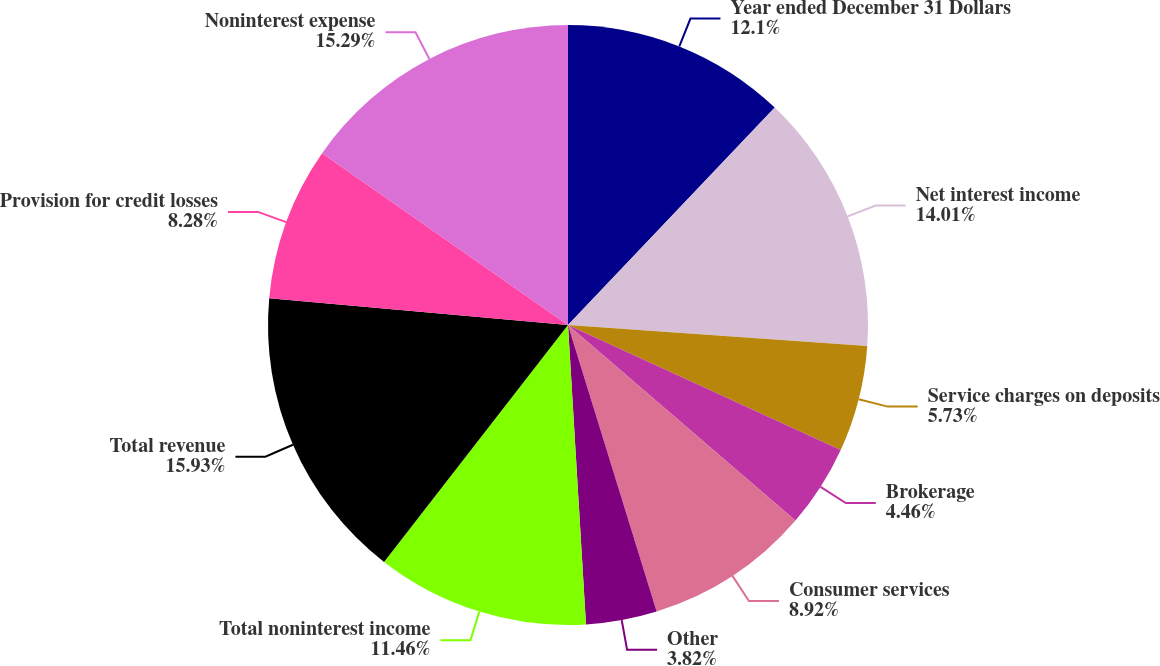<chart> <loc_0><loc_0><loc_500><loc_500><pie_chart><fcel>Year ended December 31 Dollars<fcel>Net interest income<fcel>Service charges on deposits<fcel>Brokerage<fcel>Consumer services<fcel>Other<fcel>Total noninterest income<fcel>Total revenue<fcel>Provision for credit losses<fcel>Noninterest expense<nl><fcel>12.1%<fcel>14.01%<fcel>5.73%<fcel>4.46%<fcel>8.92%<fcel>3.82%<fcel>11.46%<fcel>15.92%<fcel>8.28%<fcel>15.29%<nl></chart> 